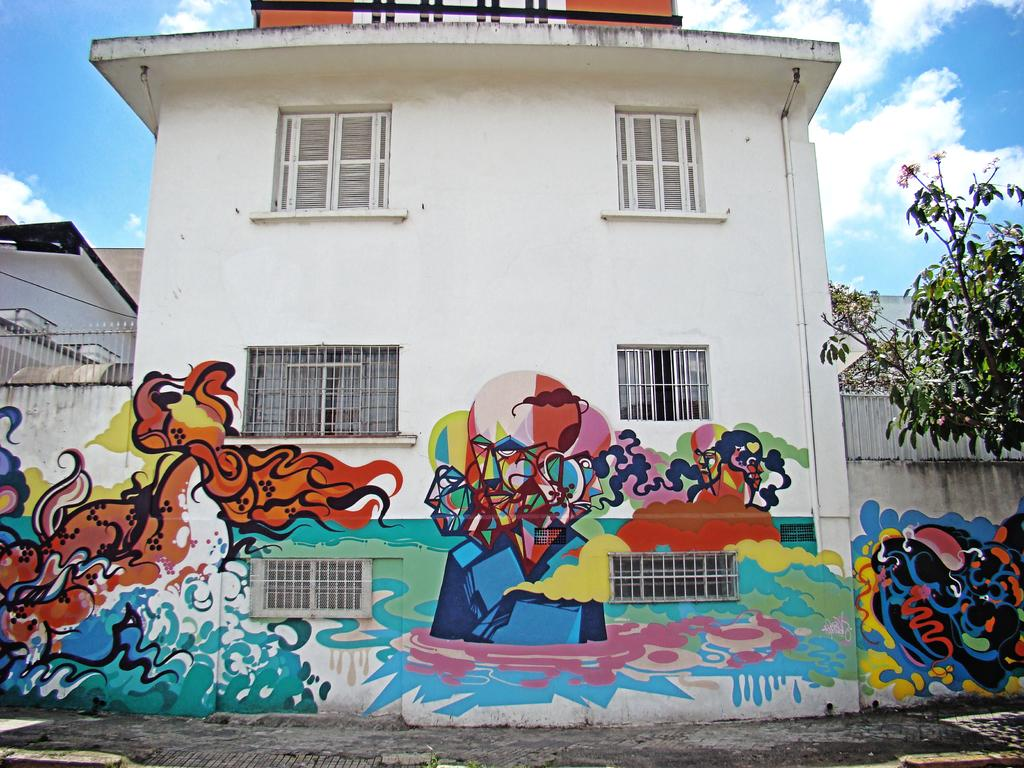What type of structures can be seen in the image? There are buildings in the image. What decorative elements are present on the buildings? Paintings are visible on the buildings. What architectural feature is common among the buildings? Windows are present on the buildings. What is visible at the top of the image? The sky is visible at the top of the image. What type of vegetation is on the right side of the image? There is a tree on the right side of the image. How many times does the tree fall in the image? There is no tree falling in the image; it is standing on the right side of the image. 